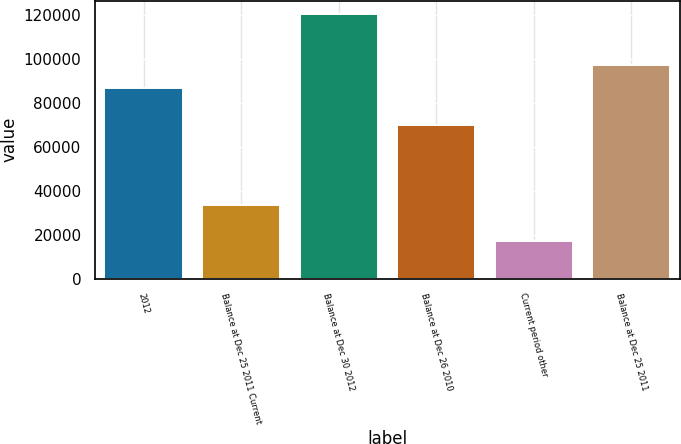Convert chart to OTSL. <chart><loc_0><loc_0><loc_500><loc_500><bar_chart><fcel>2012<fcel>Balance at Dec 25 2011 Current<fcel>Balance at Dec 30 2012<fcel>Balance at Dec 26 2010<fcel>Current period other<fcel>Balance at Dec 25 2011<nl><fcel>86822<fcel>33600<fcel>120422<fcel>69925<fcel>16897<fcel>97174.5<nl></chart> 